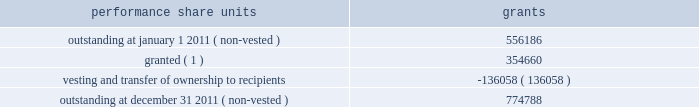During the year ended december 31 , 2011 , we granted 354660 performance share units having a fair value based on our grant date closing stock price of $ 28.79 .
These units are payable in stock and are subject to certain financial performance criteria .
The fair value of these performance share unit awards is based on the grant date closing stock price of each respective award grant and will apply to the number of units ultimately awarded .
The number of shares ultimately issued for each award will be based on our financial performance as compared to peer group companies over the performance period and can range from zero to 200% ( 200 % ) .
As of december 31 , 2011 , estimated share payouts for outstanding non-vested performance share unit awards ranged from 150% ( 150 % ) to 195% ( 195 % ) .
For the legacy frontier performance share units assumed at july 1 , 2011 , performance is based on market performance criteria , which is calculated as the total shareholder return achieved by hollyfrontier stockholders compared with the average shareholder return achieved by an equally-weighted peer group of independent refining companies over a three-year period .
These share unit awards are payable in stock based on share price performance relative to the defined peer group and can range from zero to 125% ( 125 % ) of the initial target award .
These performance share units were valued at july 1 , 2011 using a monte carlo valuation model , which simulates future stock price movements using key inputs including grant date and measurement date stock prices , expected stock price performance , expected rate of return and volatility of our stock price relative to the peer group over the three-year performance period .
The fair value of these performance share units at july 1 , 2011 was $ 8.6 million .
Of this amount , $ 7.3 million relates to post-merger services and will be recognized ratably over the remaining service period through 2013 .
A summary of performance share unit activity and changes during the year ended december 31 , 2011 is presented below: .
( 1 ) includes 225116 non-vested performance share grants under the legacy frontier plan that were outstanding and retained by hollyfrontier at july 1 , 2011 .
For the year ended december 31 , 2011 we issued 178148 shares of our common stock having a fair value of $ 2.6 million related to vested performance share units .
Based on the weighted average grant date fair value of $ 20.71 there was $ 11.7 million of total unrecognized compensation cost related to non-vested performance share units .
That cost is expected to be recognized over a weighted-average period of 1.1 years .
Note 7 : cash and cash equivalents and investments in marketable securities our investment portfolio at december 31 , 2011 consisted of cash , cash equivalents and investments in debt securities primarily issued by government and municipal entities .
We also hold 1000000 shares of connacher oil and gas limited common stock that was received as partial consideration upon the sale of our montana refinery in we invest in highly-rated marketable debt securities , primarily issued by government and municipal entities that have maturities at the date of purchase of greater than three months .
We also invest in other marketable debt securities with the maximum maturity or put date of any individual issue generally not greater than two years from the date of purchase .
All of these instruments , including investments in equity securities , are classified as available- for-sale .
As a result , they are reported at fair value using quoted market prices .
Interest income is recorded as earned .
Unrealized gains and losses , net of related income taxes , are reported as a component of accumulated other comprehensive income .
Upon sale , realized gains and losses on the sale of marketable securities are computed based on the specific identification of the underlying cost of the securities sold and the unrealized gains and losses previously reported in other comprehensive income are reclassified to current earnings. .
What percentage of the fair value of performance share units at july 1 , 2011 was relates to to post-merger services and will be recognized ratably over the remaining service period through 2013? 
Computations: (7.3 / 8.6)
Answer: 0.84884. 